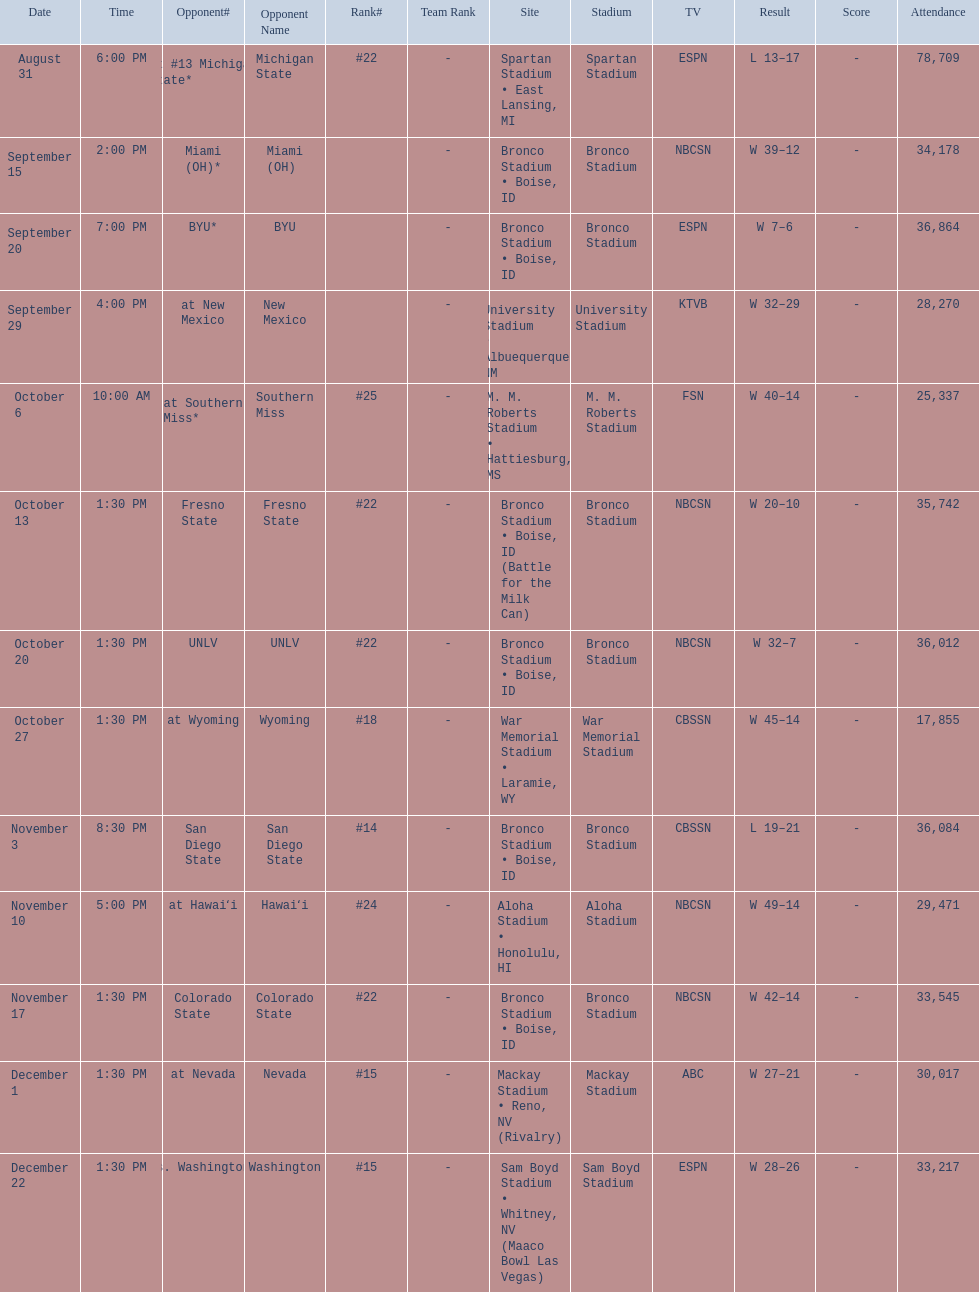What are the opponent teams of the 2012 boise state broncos football team? At #13 michigan state*, miami (oh)*, byu*, at new mexico, at southern miss*, fresno state, unlv, at wyoming, san diego state, at hawaiʻi, colorado state, at nevada, vs. washington*. How has the highest rank of these opponents? San Diego State. 